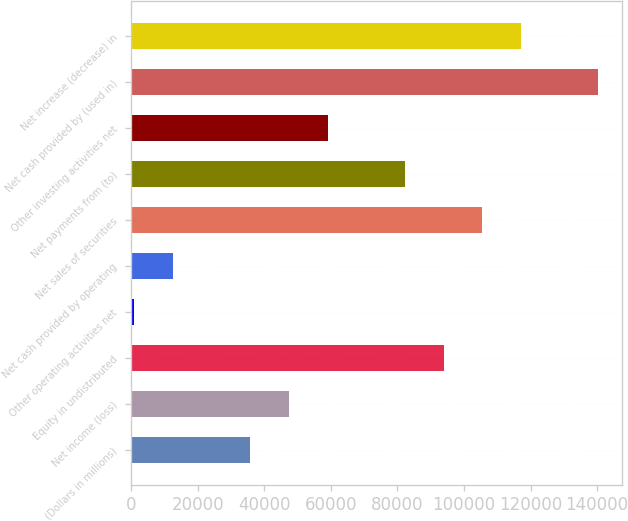Convert chart. <chart><loc_0><loc_0><loc_500><loc_500><bar_chart><fcel>(Dollars in millions)<fcel>Net income (loss)<fcel>Equity in undistributed<fcel>Other operating activities net<fcel>Net cash provided by operating<fcel>Net sales of securities<fcel>Net payments from (to)<fcel>Other investing activities net<fcel>Net cash provided by (used in)<fcel>Net increase (decrease) in<nl><fcel>35834.4<fcel>47447.2<fcel>93898.4<fcel>996<fcel>12608.8<fcel>105511<fcel>82285.6<fcel>59060<fcel>140350<fcel>117124<nl></chart> 